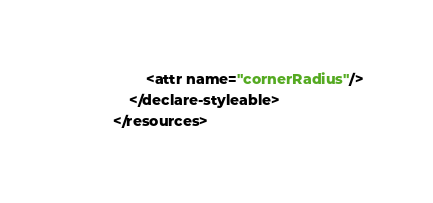Convert code to text. <code><loc_0><loc_0><loc_500><loc_500><_XML_>        <attr name="cornerRadius"/>
    </declare-styleable>
</resources></code> 